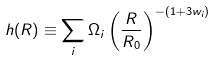<formula> <loc_0><loc_0><loc_500><loc_500>h ( R ) \equiv \sum _ { i } \Omega _ { i } \left ( \frac { R } { R _ { 0 } } \right ) ^ { - ( 1 + 3 w _ { i } ) }</formula> 